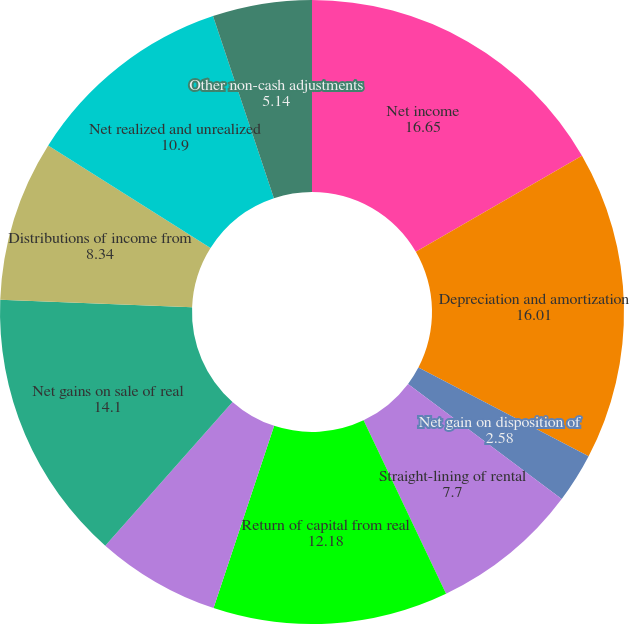<chart> <loc_0><loc_0><loc_500><loc_500><pie_chart><fcel>Net income<fcel>Depreciation and amortization<fcel>Net gain on disposition of<fcel>Straight-lining of rental<fcel>Return of capital from real<fcel>Amortization of below-market<fcel>Net gains on sale of real<fcel>Distributions of income from<fcel>Net realized and unrealized<fcel>Other non-cash adjustments<nl><fcel>16.65%<fcel>16.01%<fcel>2.58%<fcel>7.7%<fcel>12.18%<fcel>6.42%<fcel>14.1%<fcel>8.34%<fcel>10.9%<fcel>5.14%<nl></chart> 